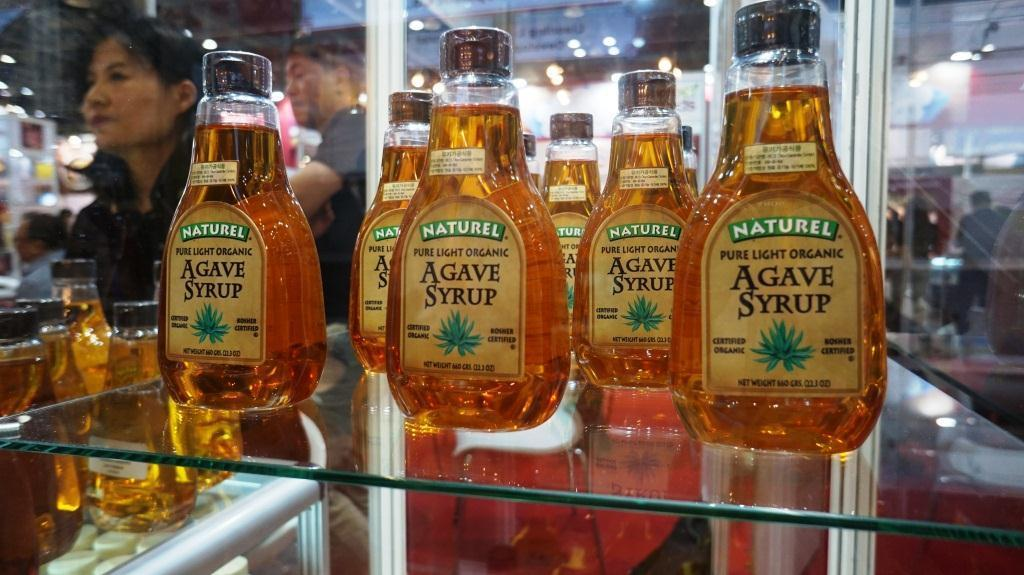<image>
Relay a brief, clear account of the picture shown. A display of bottles of Agave sryup by Naturel. 